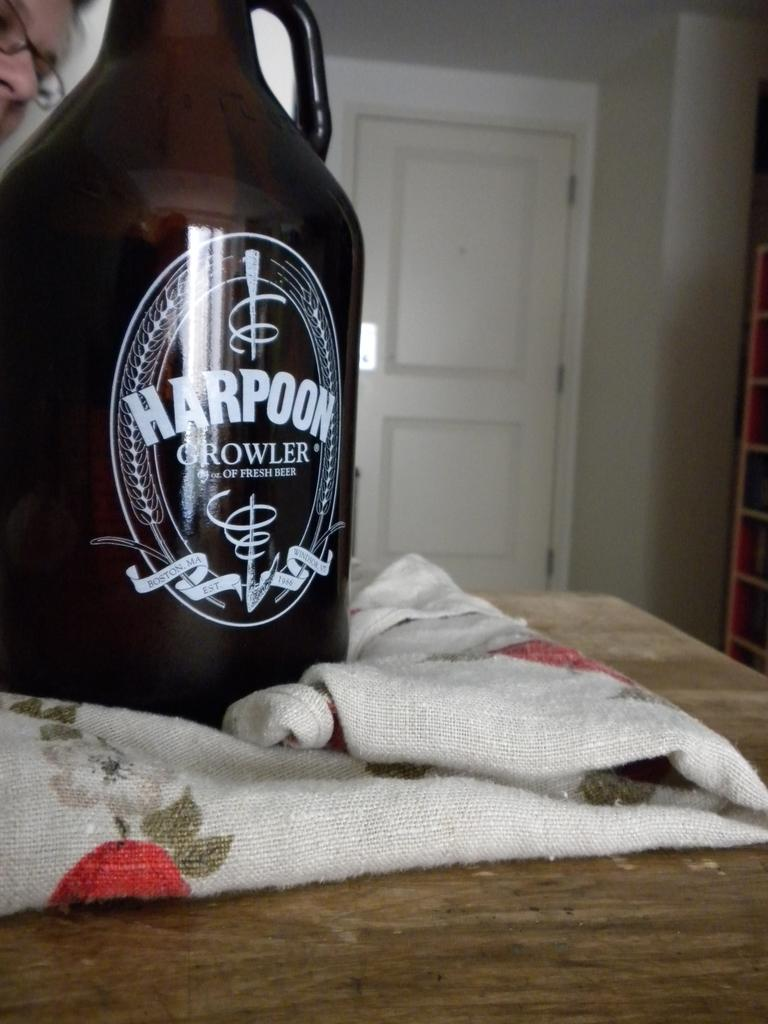<image>
Provide a brief description of the given image. bottle of alcohol called harpoon growler on the table 